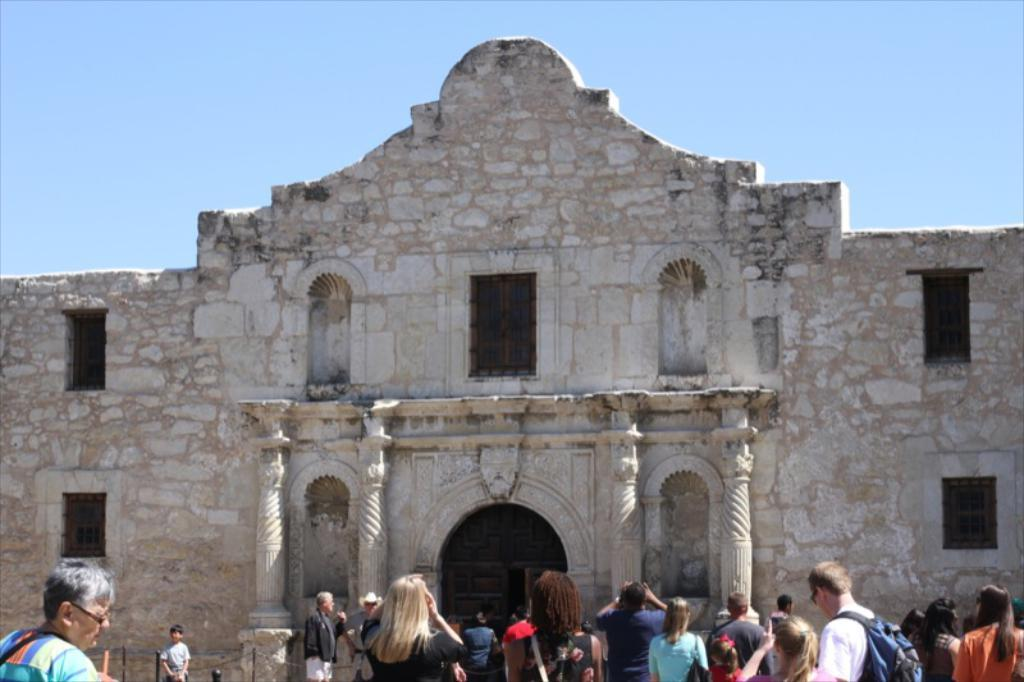What can be seen at the bottom of the image? There are people at the bottom of the image. What is located in the background of the image? There is a stone structure in the background of the image. What features does the stone structure have? The stone structure has windows, a door, and pillars. What is visible at the top of the image? The sky is visible at the top of the image. What type of prose is being recited by the people at the bottom of the image? There is no indication in the image that the people are reciting any prose. How does the stone structure help the people in the image? The image does not provide any information about the stone structure helping the people, nor does it show any interaction between the people and the structure. 